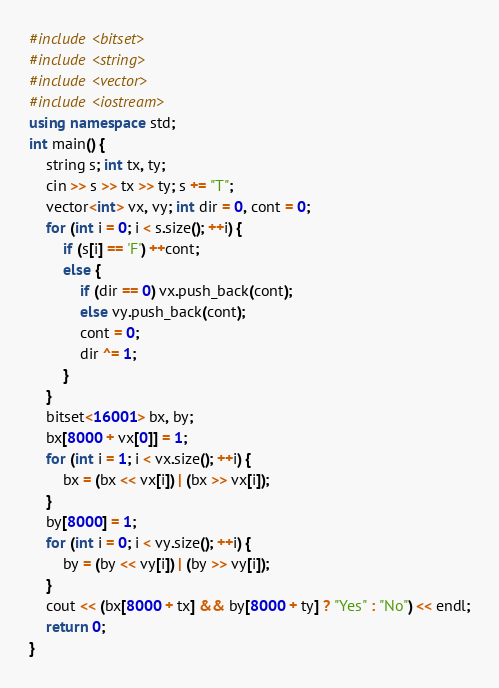Convert code to text. <code><loc_0><loc_0><loc_500><loc_500><_C++_>#include <bitset>
#include <string>
#include <vector>
#include <iostream>
using namespace std;
int main() {
	string s; int tx, ty;
	cin >> s >> tx >> ty; s += "T";
	vector<int> vx, vy; int dir = 0, cont = 0;
	for (int i = 0; i < s.size(); ++i) {
		if (s[i] == 'F') ++cont;
		else {
			if (dir == 0) vx.push_back(cont);
			else vy.push_back(cont);
			cont = 0;
			dir ^= 1;
		}
	}
	bitset<16001> bx, by;
	bx[8000 + vx[0]] = 1;
	for (int i = 1; i < vx.size(); ++i) {
		bx = (bx << vx[i]) | (bx >> vx[i]);
	}
	by[8000] = 1;
	for (int i = 0; i < vy.size(); ++i) {
		by = (by << vy[i]) | (by >> vy[i]);
	}
	cout << (bx[8000 + tx] && by[8000 + ty] ? "Yes" : "No") << endl;
	return 0;
}</code> 